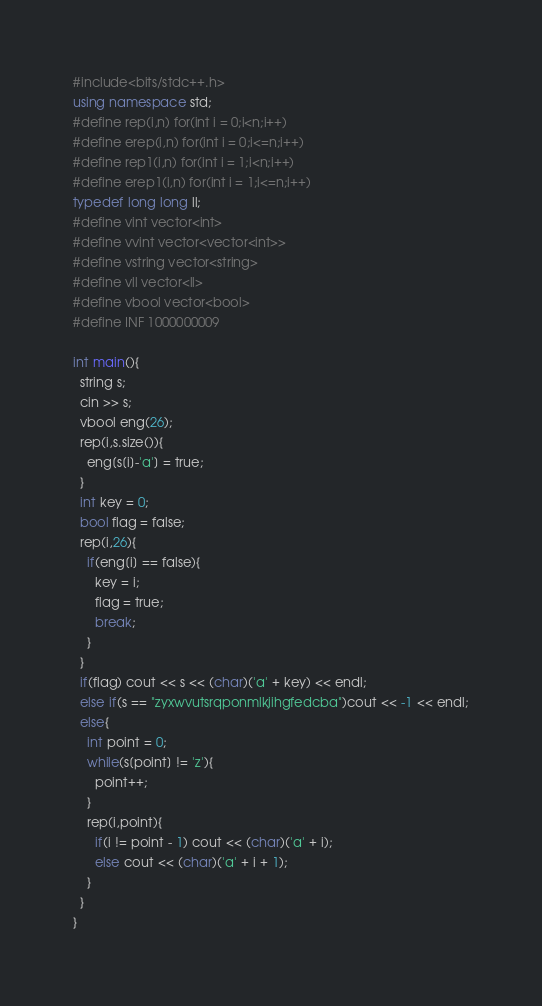Convert code to text. <code><loc_0><loc_0><loc_500><loc_500><_C++_>#include<bits/stdc++.h>
using namespace std;
#define rep(i,n) for(int i = 0;i<n;i++)
#define erep(i,n) for(int i = 0;i<=n;i++)
#define rep1(i,n) for(int i = 1;i<n;i++)
#define erep1(i,n) for(int i = 1;i<=n;i++)
typedef long long ll;
#define vint vector<int>
#define vvint vector<vector<int>>
#define vstring vector<string>
#define vll vector<ll>
#define vbool vector<bool>
#define INF 1000000009

int main(){
  string s;
  cin >> s;
  vbool eng(26);
  rep(i,s.size()){
    eng[s[i]-'a'] = true;
  }
  int key = 0;
  bool flag = false;
  rep(i,26){
    if(eng[i] == false){
      key = i;
      flag = true;
      break;
    }
  }
  if(flag) cout << s << (char)('a' + key) << endl;
  else if(s == "zyxwvutsrqponmlkjihgfedcba")cout << -1 << endl;
  else{
    int point = 0;
    while(s[point] != 'z'){
      point++;
    }
    rep(i,point){
      if(i != point - 1) cout << (char)('a' + i);
      else cout << (char)('a' + i + 1);
    }
  }
}
</code> 